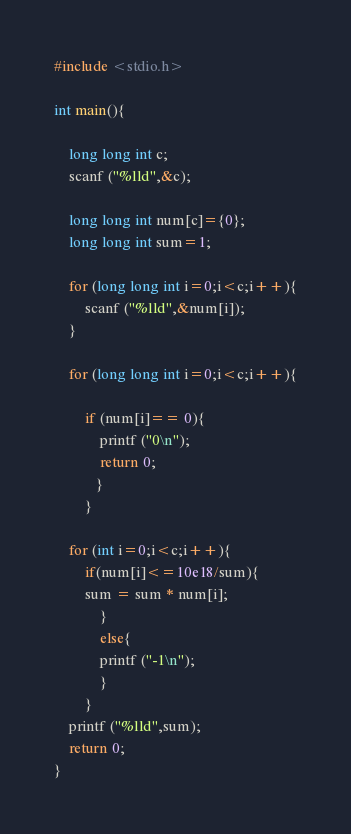<code> <loc_0><loc_0><loc_500><loc_500><_C_>#include <stdio.h>

int main(){
	
	long long int c;
	scanf ("%lld",&c);
	
	long long int num[c]={0};
	long long int sum=1;
	
	for (long long int i=0;i<c;i++){
		scanf ("%lld",&num[i]);
	}

	for (long long int i=0;i<c;i++){
		
		if (num[i]== 0){
			printf ("0\n");
			return 0;
           }
		}
		
	for (int i=0;i<c;i++){
		if(num[i]<=10e18/sum){
		sum = sum * num[i];
			}
			else{
			printf ("-1\n");
			}
		}
	printf ("%lld",sum);
	return 0;
}</code> 